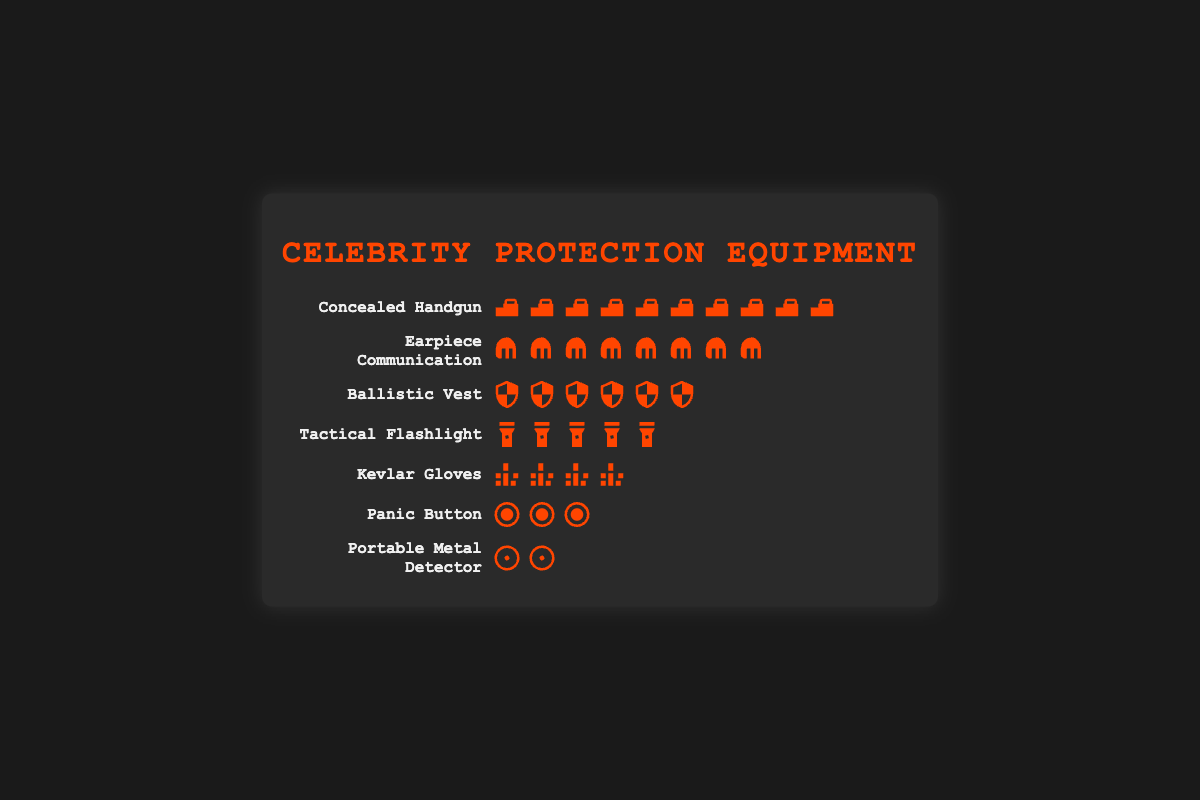Which piece of equipment is used the most frequently? By counting the icons for each piece of equipment, we see that the Concealed Handgun has the most icons (10).
Answer: Concealed Handgun What is the total number of pieces of equipment depicted? Add up the counts for each type of equipment: 10 (Handgun) + 8 (Earpiece) + 6 (Vest) + 5 (Flashlight) + 4 (Gloves) + 3 (Panic Button) + 2 (Metal Detector) = 38.
Answer: 38 How many more Concealed Handguns are used compared to Kevlar Gloves? Count the icons for Concealed Handgun (10) and Kevlar Gloves (4) and find the difference: 10 - 4 = 6.
Answer: 6 Which two pieces of equipment have the closest number of uses, and what are their counts? Compare the counts: Earpiece (8) and Ballistic Vest (6) are closest in number.
Answer: Earpiece (8) and Ballistic Vest (6) What is the average number of uses per equipment type? Add up all the counts (38) and divide by the number of equipment types (7): 38 / 7 ≈ 5.43.
Answer: Approximately 5.43 Which piece of equipment has half the frequency of the Concealed Handgun, and what is its count? Concealed Handgun count is 10; half of that is 5, which matches the Tactical Flashlight count.
Answer: Tactical Flashlight (5) How many fewer Panic Buttons are there compared to Ballistic Vests? Count the icons for Panic Buttons (3) and Ballistic Vests (6) and find the difference: 6 - 3 = 3.
Answer: 3 Which piece of equipment is the least frequently used? The Portable Metal Detector has the least number of icons (2).
Answer: Portable Metal Detector 